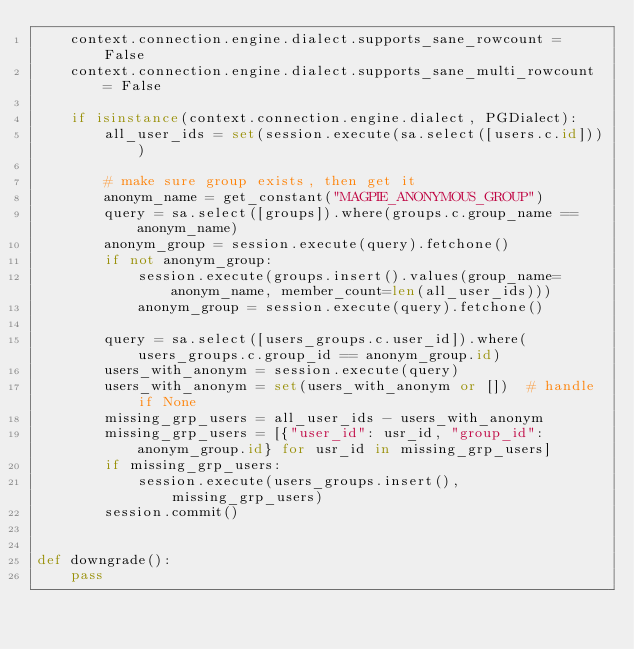<code> <loc_0><loc_0><loc_500><loc_500><_Python_>    context.connection.engine.dialect.supports_sane_rowcount = False
    context.connection.engine.dialect.supports_sane_multi_rowcount = False

    if isinstance(context.connection.engine.dialect, PGDialect):
        all_user_ids = set(session.execute(sa.select([users.c.id])))

        # make sure group exists, then get it
        anonym_name = get_constant("MAGPIE_ANONYMOUS_GROUP")
        query = sa.select([groups]).where(groups.c.group_name == anonym_name)
        anonym_group = session.execute(query).fetchone()
        if not anonym_group:
            session.execute(groups.insert().values(group_name=anonym_name, member_count=len(all_user_ids)))
            anonym_group = session.execute(query).fetchone()

        query = sa.select([users_groups.c.user_id]).where(users_groups.c.group_id == anonym_group.id)
        users_with_anonym = session.execute(query)
        users_with_anonym = set(users_with_anonym or [])  # handle if None
        missing_grp_users = all_user_ids - users_with_anonym
        missing_grp_users = [{"user_id": usr_id, "group_id": anonym_group.id} for usr_id in missing_grp_users]
        if missing_grp_users:
            session.execute(users_groups.insert(), missing_grp_users)
        session.commit()


def downgrade():
    pass
</code> 